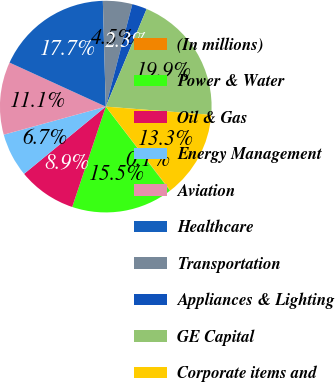Convert chart to OTSL. <chart><loc_0><loc_0><loc_500><loc_500><pie_chart><fcel>(In millions)<fcel>Power & Water<fcel>Oil & Gas<fcel>Energy Management<fcel>Aviation<fcel>Healthcare<fcel>Transportation<fcel>Appliances & Lighting<fcel>GE Capital<fcel>Corporate items and<nl><fcel>0.07%<fcel>15.52%<fcel>8.9%<fcel>6.69%<fcel>11.1%<fcel>17.73%<fcel>4.48%<fcel>2.27%<fcel>19.93%<fcel>13.31%<nl></chart> 